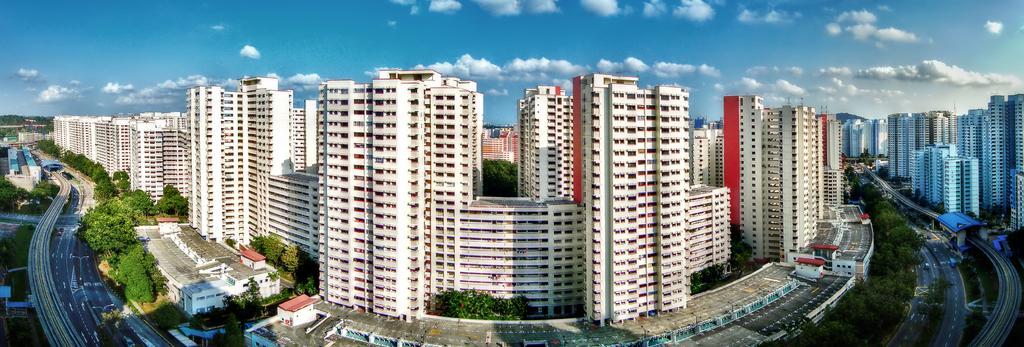In one or two sentences, can you explain what this image depicts? As we can see in the image there are buildings, trees and few vehicles on road. On the top there is sky and clouds. 